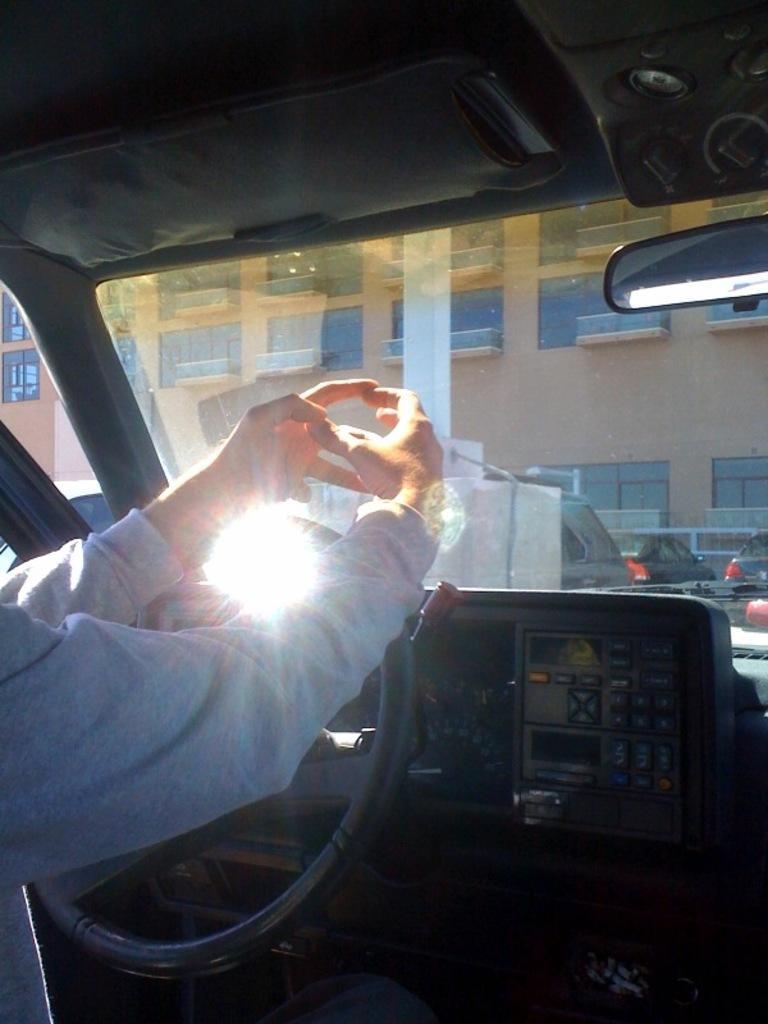Please provide a concise description of this image. In the picture we can see inside the car with person hands on the steering and beside it we can see some buttons and from the wind shield of the car we can see a building with windows and a pillar near to it and near the building we can see some cars are parked. 